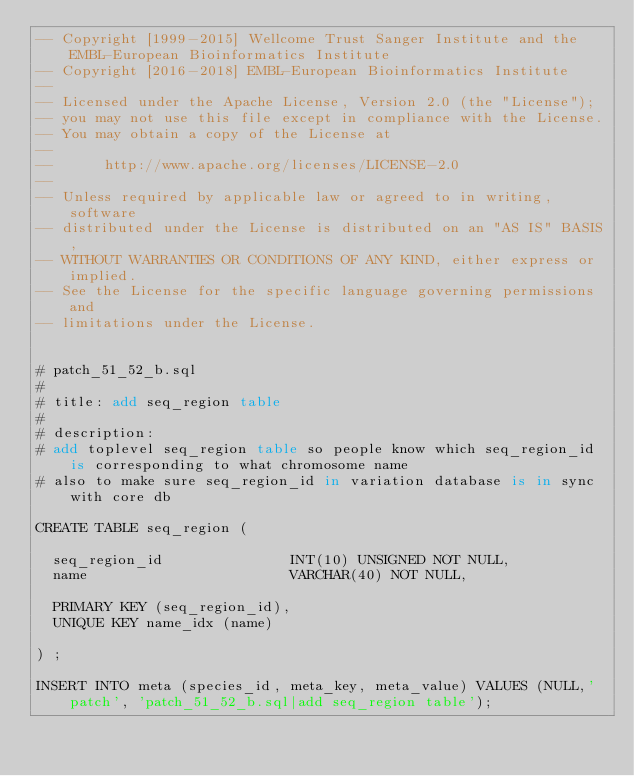<code> <loc_0><loc_0><loc_500><loc_500><_SQL_>-- Copyright [1999-2015] Wellcome Trust Sanger Institute and the EMBL-European Bioinformatics Institute
-- Copyright [2016-2018] EMBL-European Bioinformatics Institute
-- 
-- Licensed under the Apache License, Version 2.0 (the "License");
-- you may not use this file except in compliance with the License.
-- You may obtain a copy of the License at
-- 
--      http://www.apache.org/licenses/LICENSE-2.0
-- 
-- Unless required by applicable law or agreed to in writing, software
-- distributed under the License is distributed on an "AS IS" BASIS,
-- WITHOUT WARRANTIES OR CONDITIONS OF ANY KIND, either express or implied.
-- See the License for the specific language governing permissions and
-- limitations under the License.


# patch_51_52_b.sql
#
# title: add seq_region table
#
# description:
# add toplevel seq_region table so people know which seq_region_id is corresponding to what chromosome name
# also to make sure seq_region_id in variation database is in sync with core db

CREATE TABLE seq_region (

  seq_region_id               INT(10) UNSIGNED NOT NULL,
  name                        VARCHAR(40) NOT NULL,

  PRIMARY KEY (seq_region_id),
  UNIQUE KEY name_idx (name)

) ;

INSERT INTO meta (species_id, meta_key, meta_value) VALUES (NULL,'patch', 'patch_51_52_b.sql|add seq_region table');
</code> 